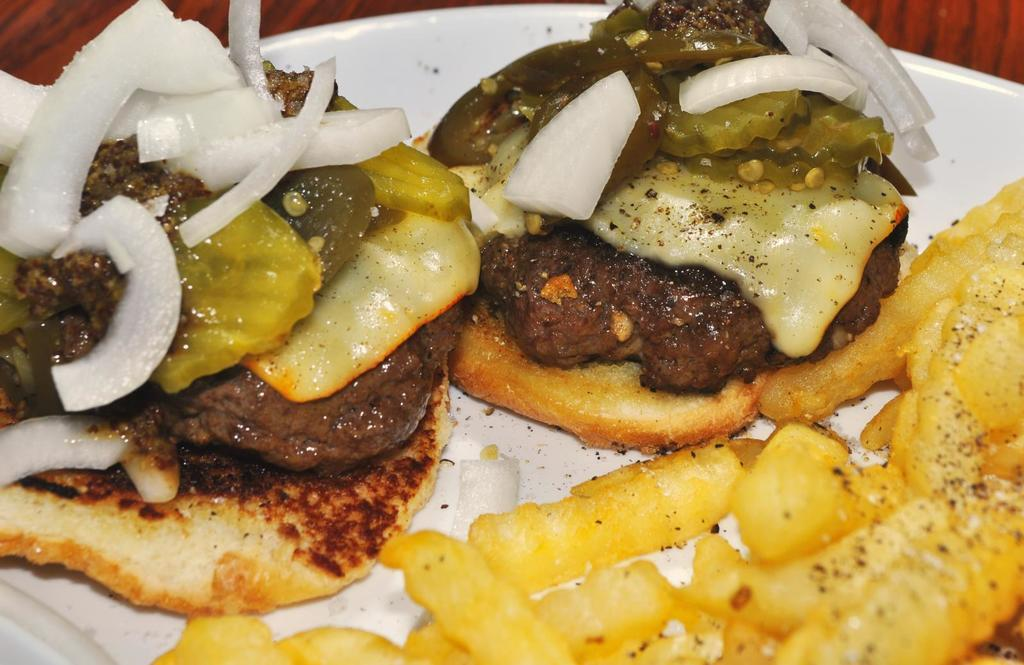What is present in the image related to food? There is food in the image. How is the food arranged or presented in the image? The food is in a white plate. How many fingers can be seen interacting with the food in the image? There are no fingers visible in the image, as it only shows food in a white plate. Can you describe how the food is kicked in the image? There is no indication in the image that the food is being kicked or interacted with in any way other than being placed in the white plate. 